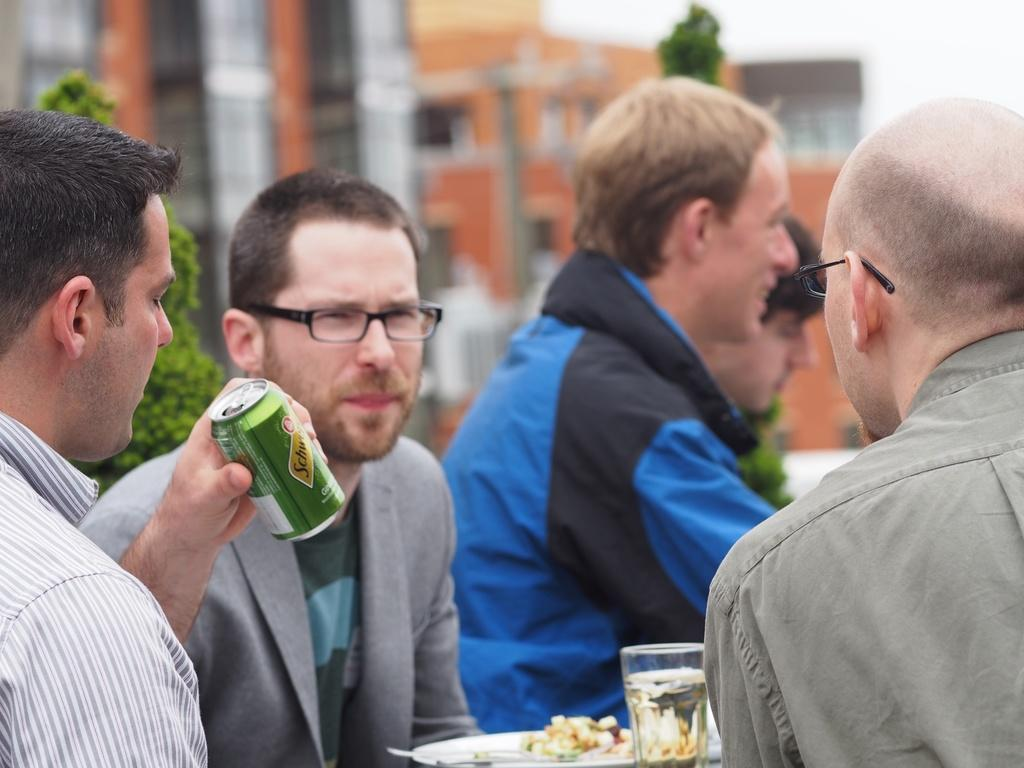How many people are in the image? There is a group of people in the image. Can you describe the appearance of some of the people? Two of the people are wearing spectacles. What is on the plate in the image? There is a plate with food in the image. What other objects can be seen in the image? There is a tin and a glass in the image. What can be seen in the background of the image? There are trees and buildings in the background of the image. How would you describe the quality of the image? The image is blurry. How much wealth does the lawyer in the image possess? There is no lawyer present in the image, and therefore no information about their wealth can be determined. What type of thunder can be heard in the image? There is no thunder present in the image, as it is a still photograph. 